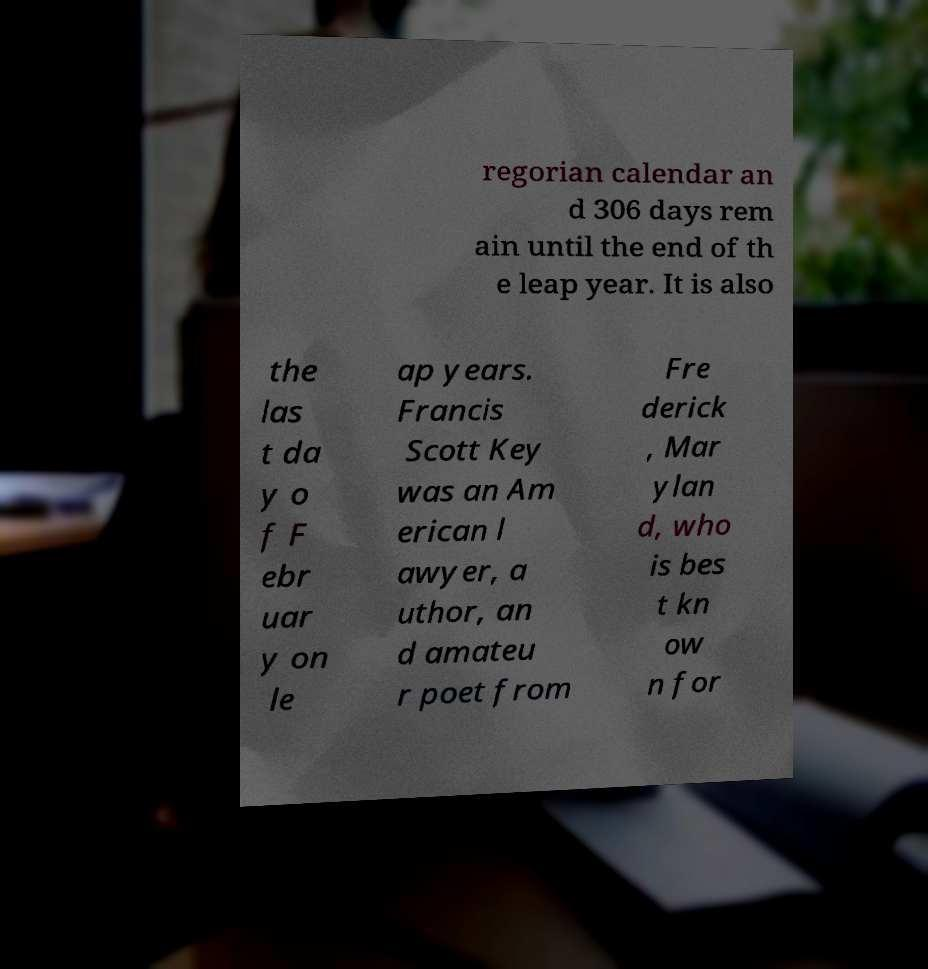Please read and relay the text visible in this image. What does it say? regorian calendar an d 306 days rem ain until the end of th e leap year. It is also the las t da y o f F ebr uar y on le ap years. Francis Scott Key was an Am erican l awyer, a uthor, an d amateu r poet from Fre derick , Mar ylan d, who is bes t kn ow n for 